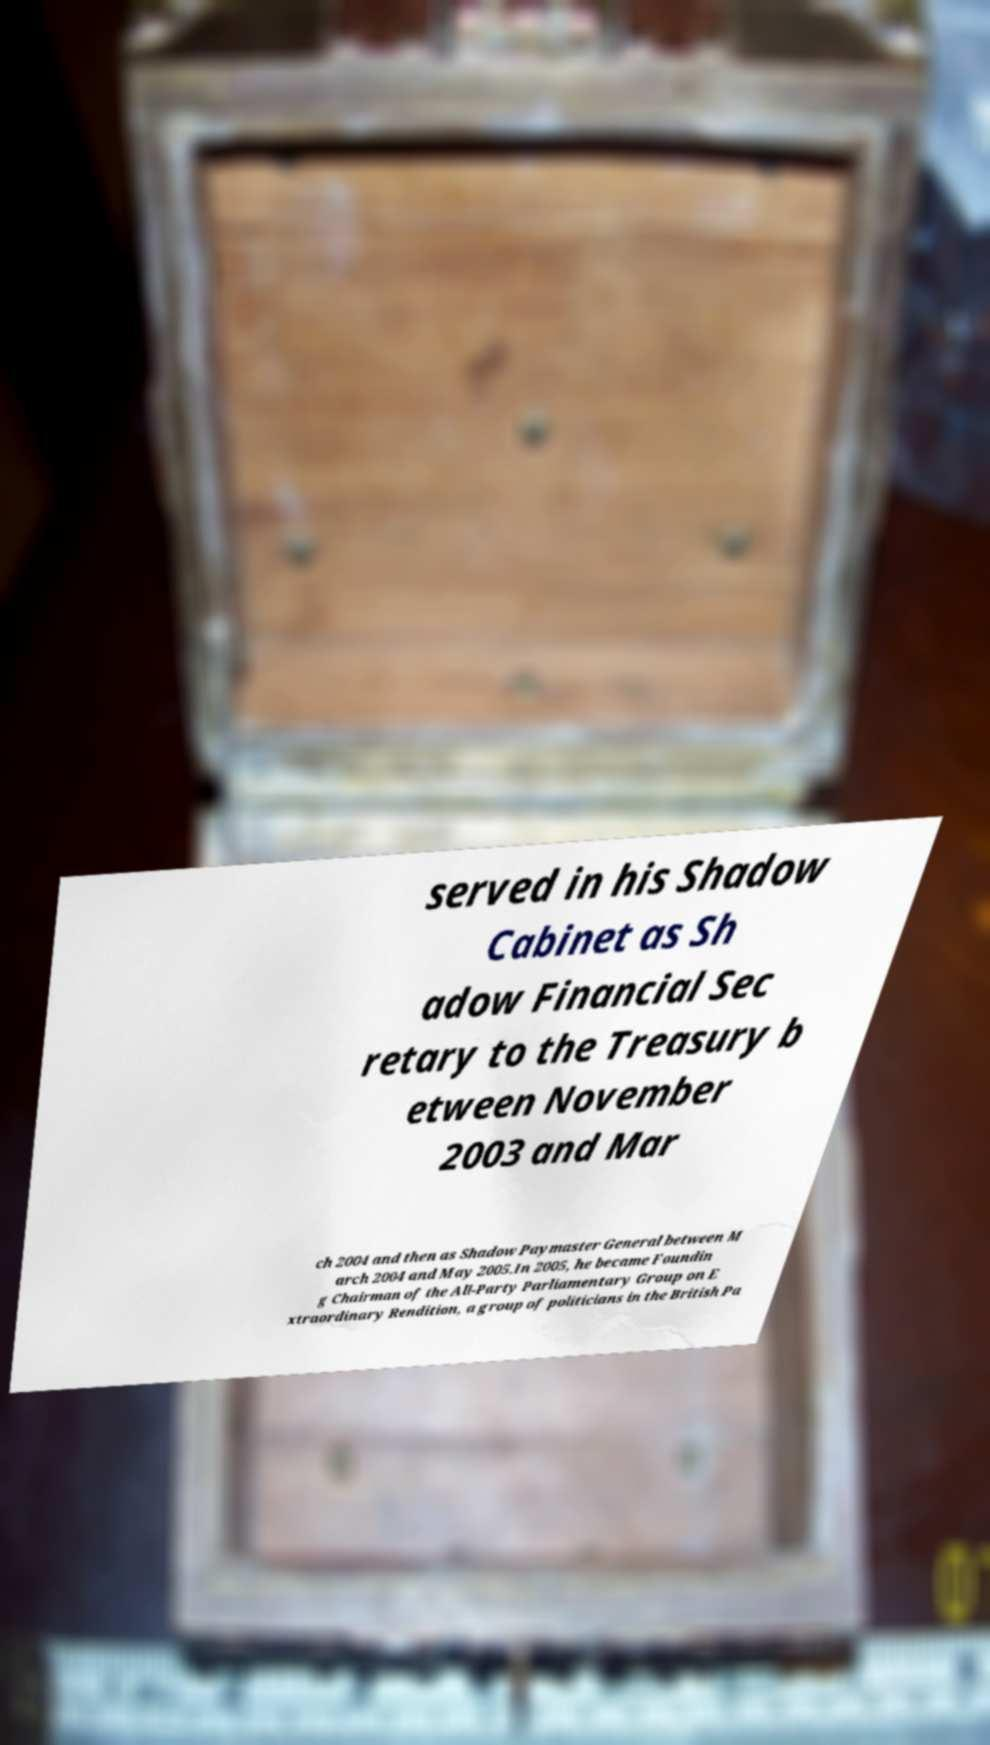Can you accurately transcribe the text from the provided image for me? served in his Shadow Cabinet as Sh adow Financial Sec retary to the Treasury b etween November 2003 and Mar ch 2004 and then as Shadow Paymaster General between M arch 2004 and May 2005.In 2005, he became Foundin g Chairman of the All-Party Parliamentary Group on E xtraordinary Rendition, a group of politicians in the British Pa 